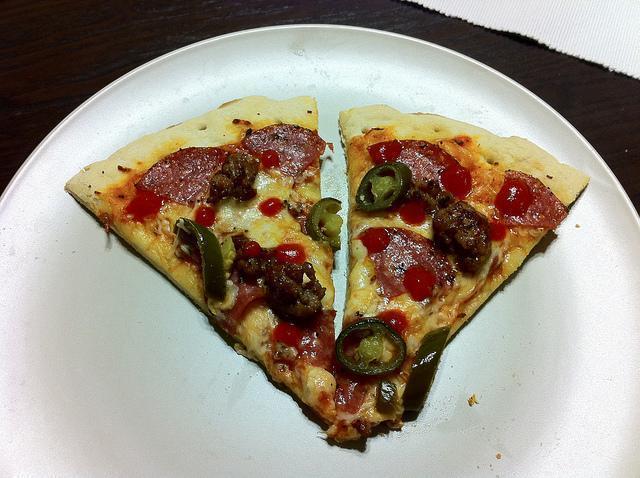How many slices of the pizza have already been eaten?
Give a very brief answer. 6. How many red buses are there?
Give a very brief answer. 0. 